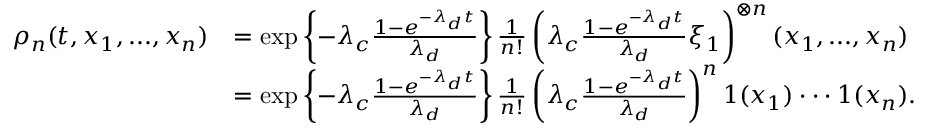Convert formula to latex. <formula><loc_0><loc_0><loc_500><loc_500>\begin{array} { r l } { \rho _ { n } ( t , x _ { 1 } , \dots , x _ { n } ) } & { = \exp \left \{ - \lambda _ { c } \frac { 1 - e ^ { - \lambda _ { d } t } } { \lambda _ { d } } \right \} \frac { 1 } { n ! } \left ( \lambda _ { c } \frac { 1 - e ^ { - \lambda _ { d } t } } { \lambda _ { d } } \xi _ { 1 } \right ) ^ { \otimes n } ( x _ { 1 } , \dots , x _ { n } ) } \\ & { = \exp \left \{ - \lambda _ { c } \frac { 1 - e ^ { - \lambda _ { d } t } } { \lambda _ { d } } \right \} \frac { 1 } { n ! } \left ( \lambda _ { c } \frac { 1 - e ^ { - \lambda _ { d } t } } { \lambda _ { d } } \right ) ^ { n } 1 ( x _ { 1 } ) \cdot \cdot \cdot 1 ( x _ { n } ) . } \end{array}</formula> 